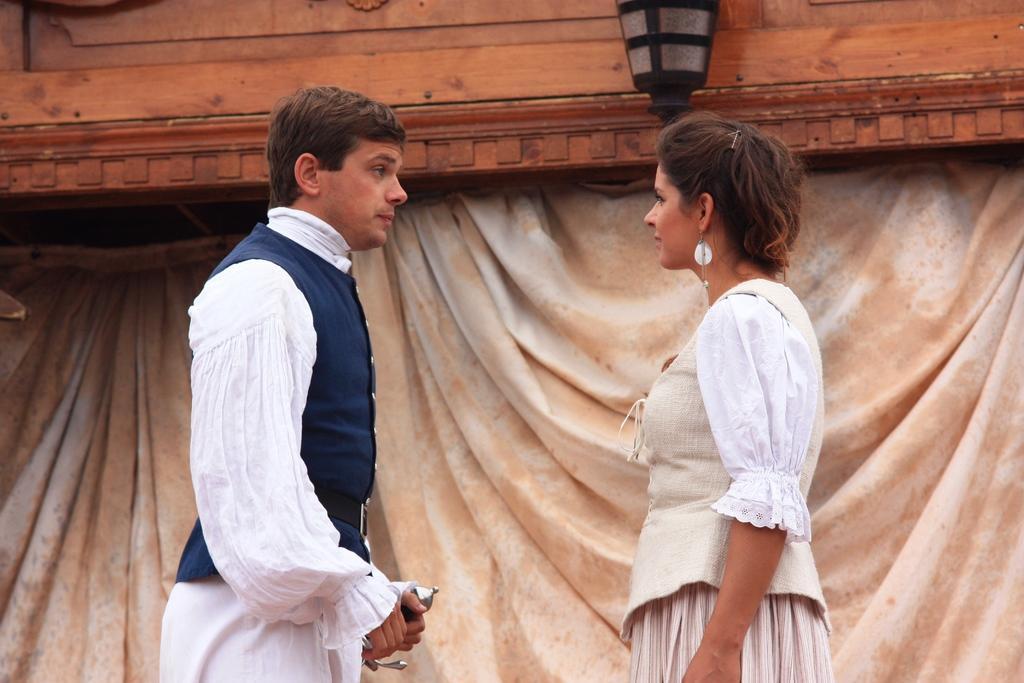Could you give a brief overview of what you see in this image? In this image we can see a man is standing and holding an object in his hand and there is a woman standing on the right side. In the background we can see light on the wall and a curtain. 